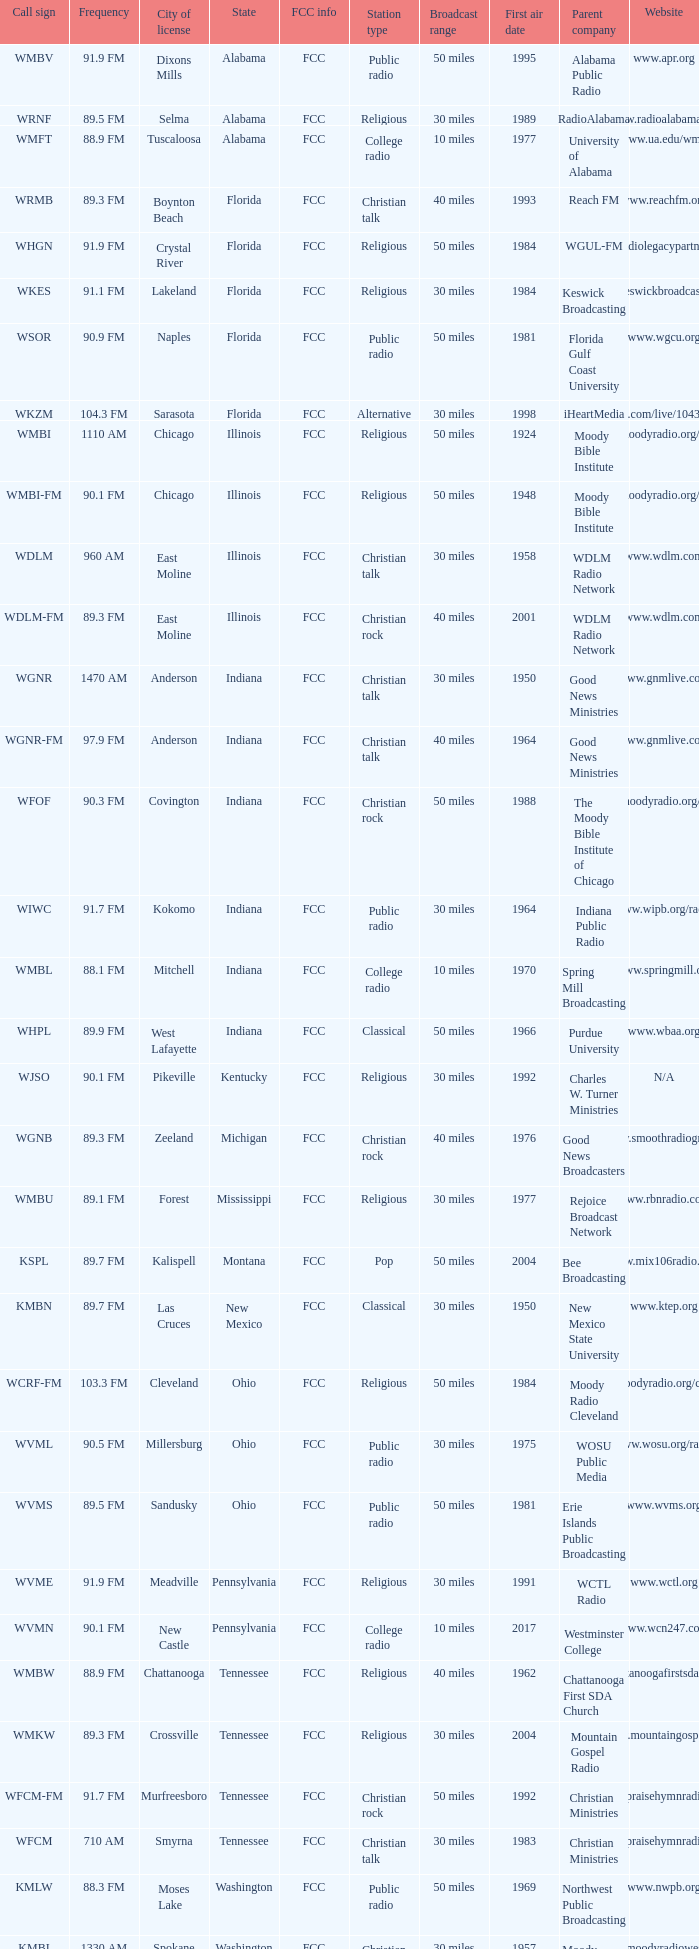What is the radio frequency of wgnr station located in indiana? 1470 AM. 